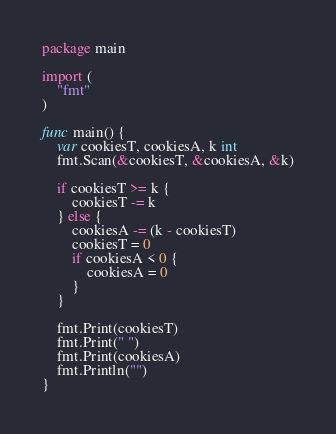<code> <loc_0><loc_0><loc_500><loc_500><_Go_>package main

import (
	"fmt"
)

func main() {
	var cookiesT, cookiesA, k int
	fmt.Scan(&cookiesT, &cookiesA, &k)

	if cookiesT >= k {
		cookiesT -= k
	} else {
		cookiesA -= (k - cookiesT)
		cookiesT = 0
		if cookiesA < 0 {
			cookiesA = 0
		}
	}

	fmt.Print(cookiesT)
	fmt.Print(" ")
	fmt.Print(cookiesA)
	fmt.Println("")
}
</code> 